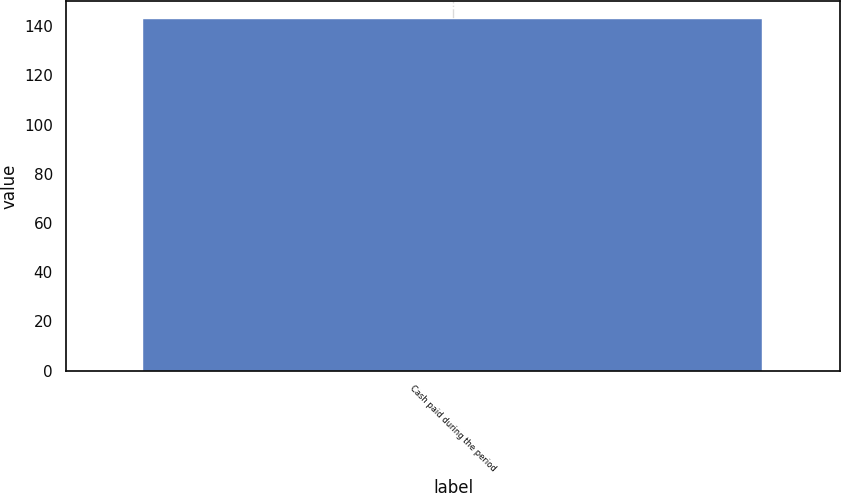Convert chart to OTSL. <chart><loc_0><loc_0><loc_500><loc_500><bar_chart><fcel>Cash paid during the period<nl><fcel>143<nl></chart> 